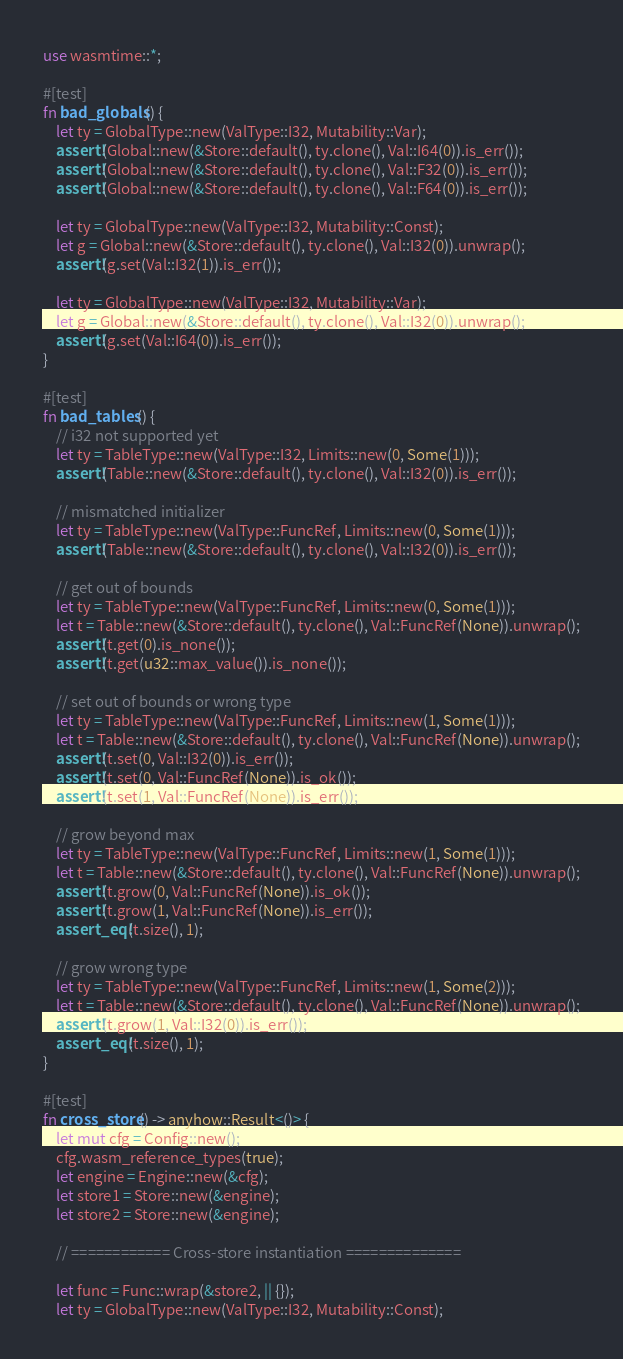Convert code to text. <code><loc_0><loc_0><loc_500><loc_500><_Rust_>use wasmtime::*;

#[test]
fn bad_globals() {
    let ty = GlobalType::new(ValType::I32, Mutability::Var);
    assert!(Global::new(&Store::default(), ty.clone(), Val::I64(0)).is_err());
    assert!(Global::new(&Store::default(), ty.clone(), Val::F32(0)).is_err());
    assert!(Global::new(&Store::default(), ty.clone(), Val::F64(0)).is_err());

    let ty = GlobalType::new(ValType::I32, Mutability::Const);
    let g = Global::new(&Store::default(), ty.clone(), Val::I32(0)).unwrap();
    assert!(g.set(Val::I32(1)).is_err());

    let ty = GlobalType::new(ValType::I32, Mutability::Var);
    let g = Global::new(&Store::default(), ty.clone(), Val::I32(0)).unwrap();
    assert!(g.set(Val::I64(0)).is_err());
}

#[test]
fn bad_tables() {
    // i32 not supported yet
    let ty = TableType::new(ValType::I32, Limits::new(0, Some(1)));
    assert!(Table::new(&Store::default(), ty.clone(), Val::I32(0)).is_err());

    // mismatched initializer
    let ty = TableType::new(ValType::FuncRef, Limits::new(0, Some(1)));
    assert!(Table::new(&Store::default(), ty.clone(), Val::I32(0)).is_err());

    // get out of bounds
    let ty = TableType::new(ValType::FuncRef, Limits::new(0, Some(1)));
    let t = Table::new(&Store::default(), ty.clone(), Val::FuncRef(None)).unwrap();
    assert!(t.get(0).is_none());
    assert!(t.get(u32::max_value()).is_none());

    // set out of bounds or wrong type
    let ty = TableType::new(ValType::FuncRef, Limits::new(1, Some(1)));
    let t = Table::new(&Store::default(), ty.clone(), Val::FuncRef(None)).unwrap();
    assert!(t.set(0, Val::I32(0)).is_err());
    assert!(t.set(0, Val::FuncRef(None)).is_ok());
    assert!(t.set(1, Val::FuncRef(None)).is_err());

    // grow beyond max
    let ty = TableType::new(ValType::FuncRef, Limits::new(1, Some(1)));
    let t = Table::new(&Store::default(), ty.clone(), Val::FuncRef(None)).unwrap();
    assert!(t.grow(0, Val::FuncRef(None)).is_ok());
    assert!(t.grow(1, Val::FuncRef(None)).is_err());
    assert_eq!(t.size(), 1);

    // grow wrong type
    let ty = TableType::new(ValType::FuncRef, Limits::new(1, Some(2)));
    let t = Table::new(&Store::default(), ty.clone(), Val::FuncRef(None)).unwrap();
    assert!(t.grow(1, Val::I32(0)).is_err());
    assert_eq!(t.size(), 1);
}

#[test]
fn cross_store() -> anyhow::Result<()> {
    let mut cfg = Config::new();
    cfg.wasm_reference_types(true);
    let engine = Engine::new(&cfg);
    let store1 = Store::new(&engine);
    let store2 = Store::new(&engine);

    // ============ Cross-store instantiation ==============

    let func = Func::wrap(&store2, || {});
    let ty = GlobalType::new(ValType::I32, Mutability::Const);</code> 